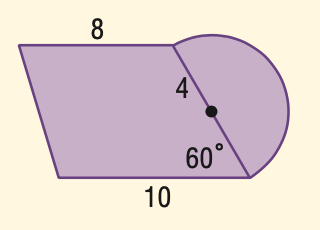Answer the mathemtical geometry problem and directly provide the correct option letter.
Question: Find the area of the figure to the nearest tenth.
Choices: A: 80.6 B: 87.5 C: 94.4 D: 112.6 B 